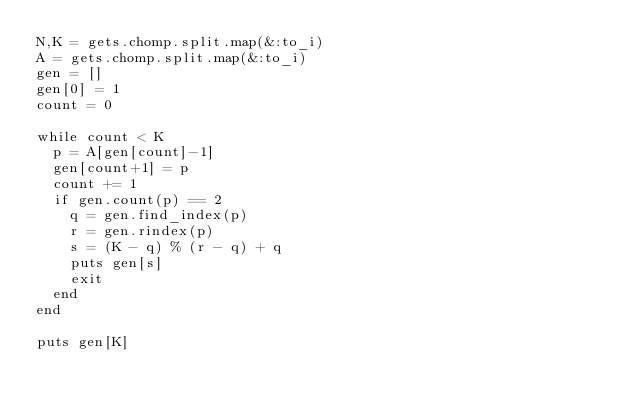Convert code to text. <code><loc_0><loc_0><loc_500><loc_500><_Ruby_>N,K = gets.chomp.split.map(&:to_i)
A = gets.chomp.split.map(&:to_i)
gen = []
gen[0] = 1
count = 0

while count < K
  p = A[gen[count]-1]
  gen[count+1] = p
  count += 1
  if gen.count(p) == 2
    q = gen.find_index(p)
    r = gen.rindex(p)
    s = (K - q) % (r - q) + q
    puts gen[s]
    exit
  end
end

puts gen[K]</code> 